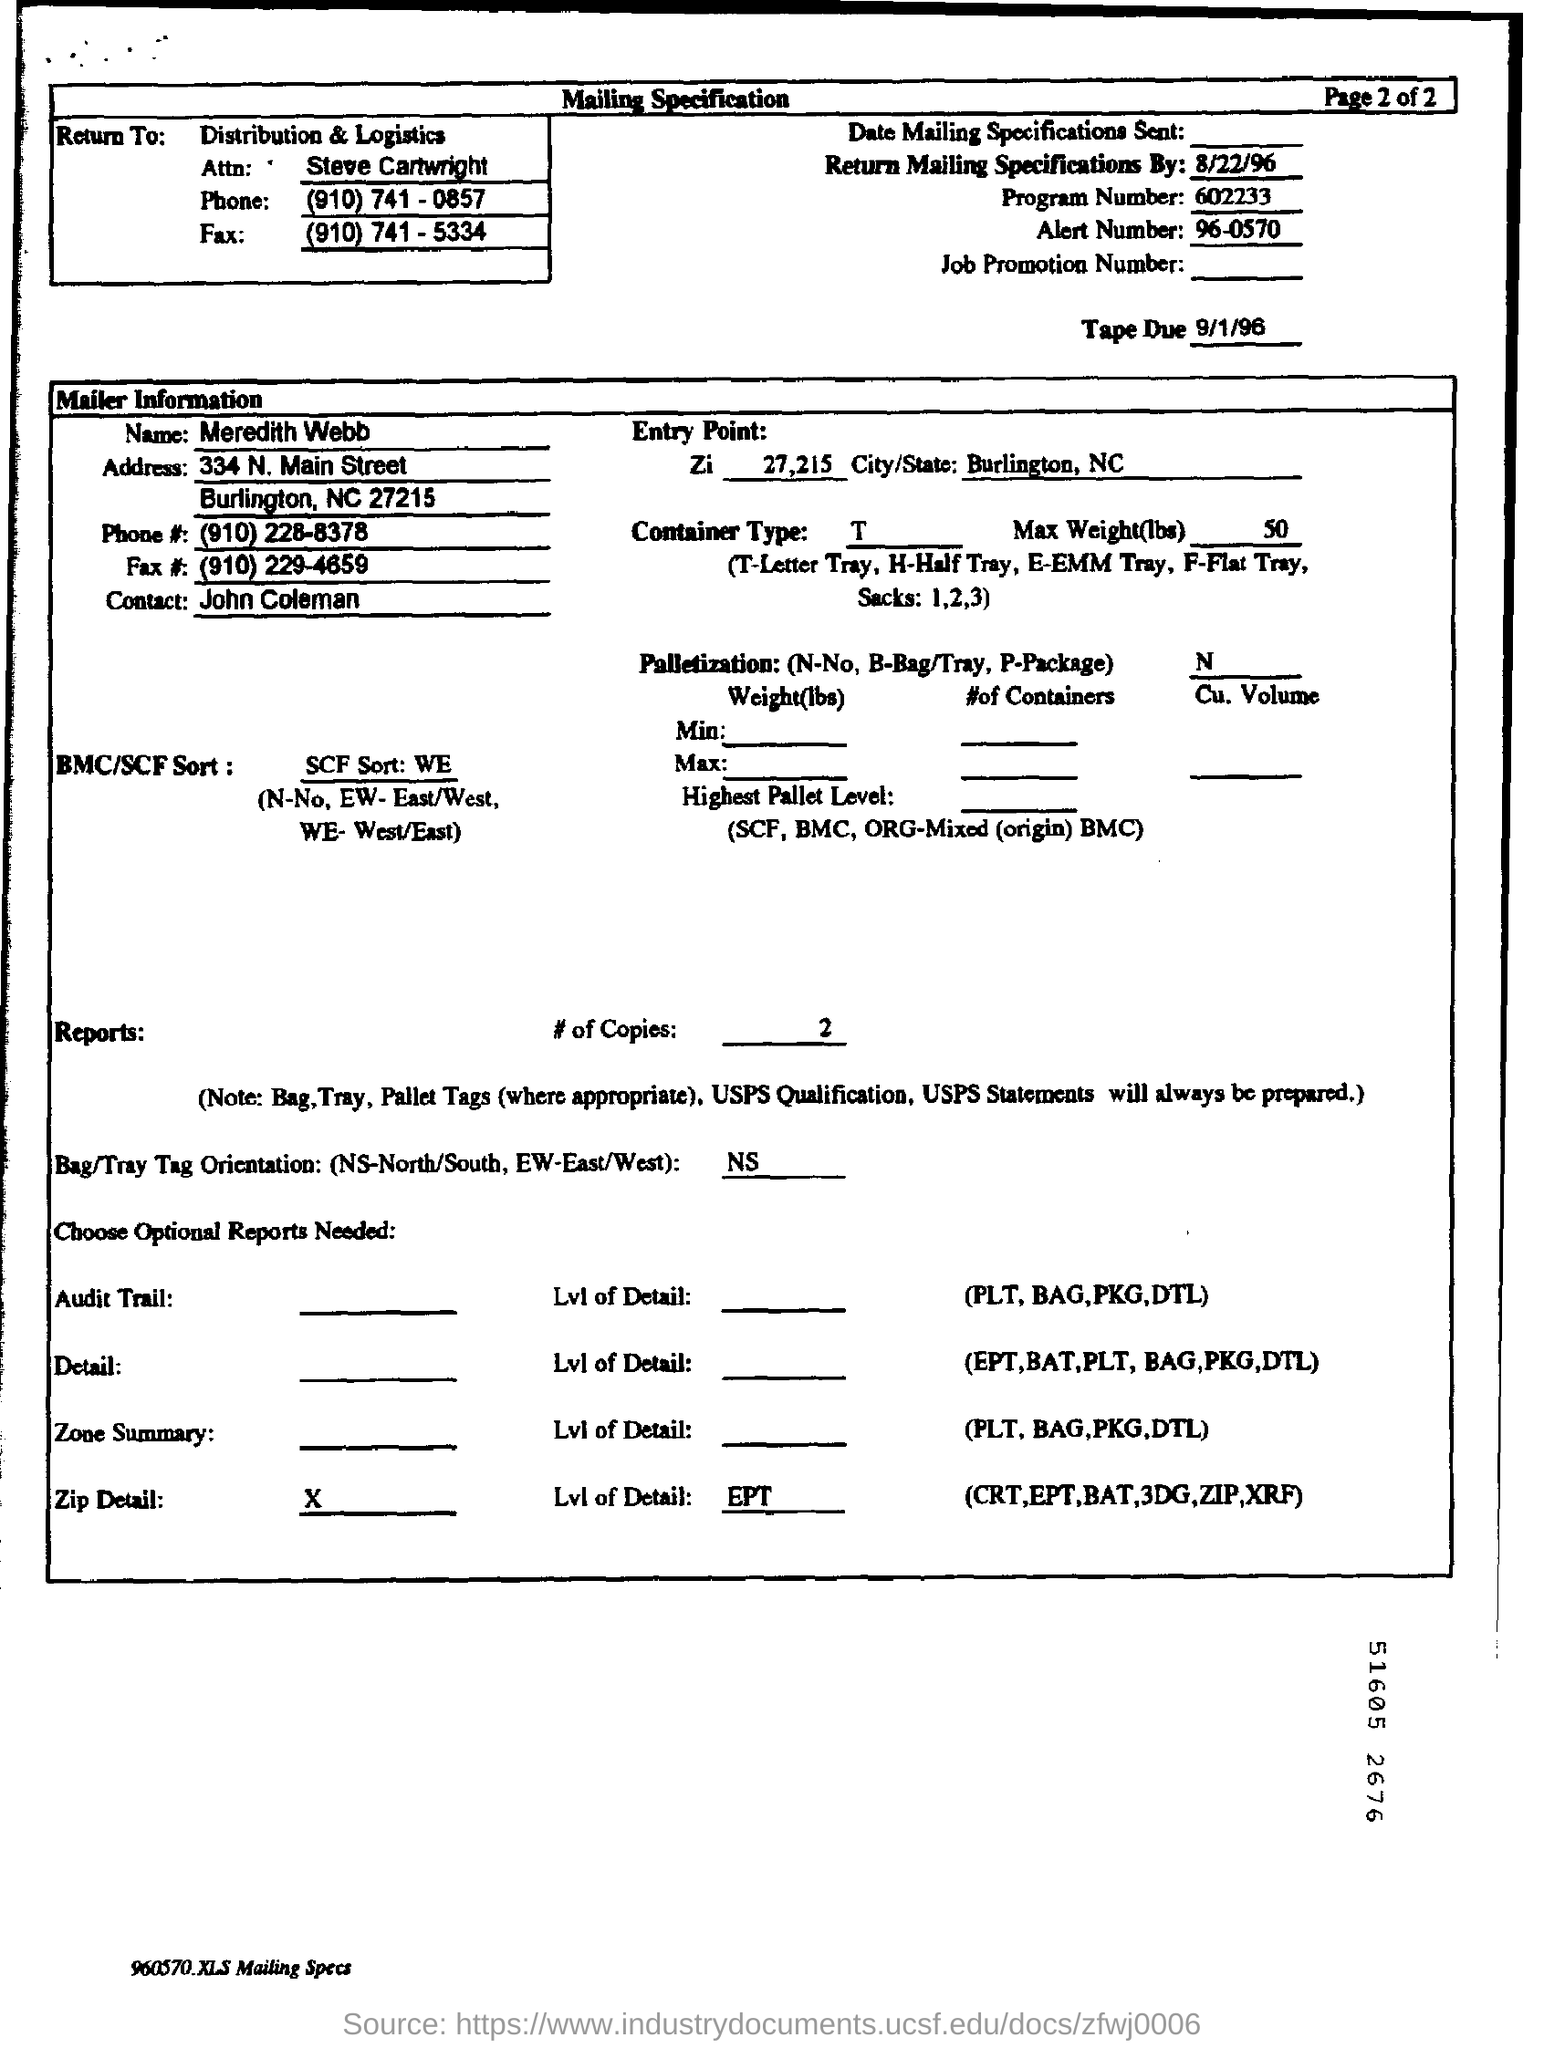What is the # of copies ?
Provide a short and direct response. 2. What is the program number ?
Provide a succinct answer. 602233. What is the alert number ?
Offer a terse response. 96-0570. 